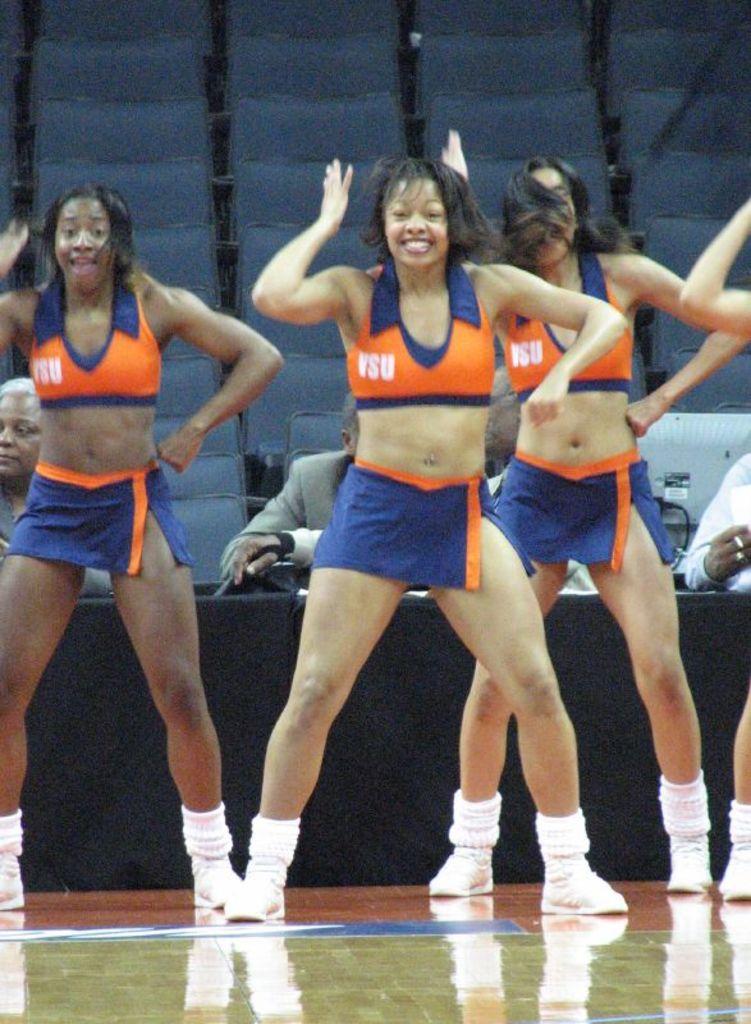What letters are on their shirts?
Offer a very short reply. Vsu. 